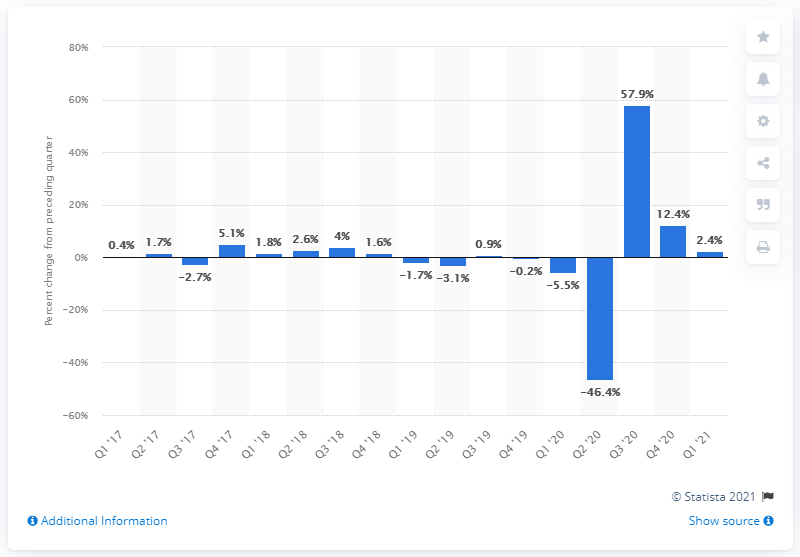List a handful of essential elements in this visual. The manufacturing sector's output increased by 2.4% in the first quarter of 2021. 